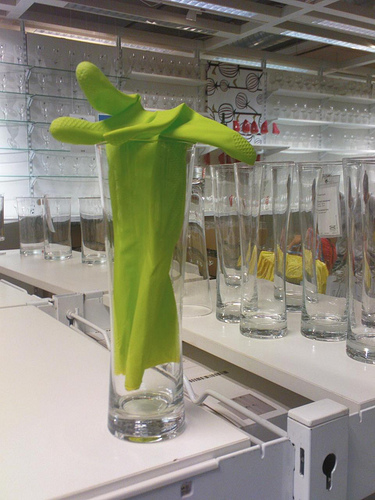<image>
Is the glass in the keyhole? No. The glass is not contained within the keyhole. These objects have a different spatial relationship. 